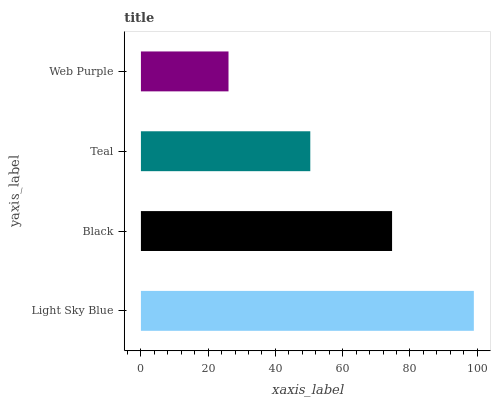Is Web Purple the minimum?
Answer yes or no. Yes. Is Light Sky Blue the maximum?
Answer yes or no. Yes. Is Black the minimum?
Answer yes or no. No. Is Black the maximum?
Answer yes or no. No. Is Light Sky Blue greater than Black?
Answer yes or no. Yes. Is Black less than Light Sky Blue?
Answer yes or no. Yes. Is Black greater than Light Sky Blue?
Answer yes or no. No. Is Light Sky Blue less than Black?
Answer yes or no. No. Is Black the high median?
Answer yes or no. Yes. Is Teal the low median?
Answer yes or no. Yes. Is Teal the high median?
Answer yes or no. No. Is Web Purple the low median?
Answer yes or no. No. 